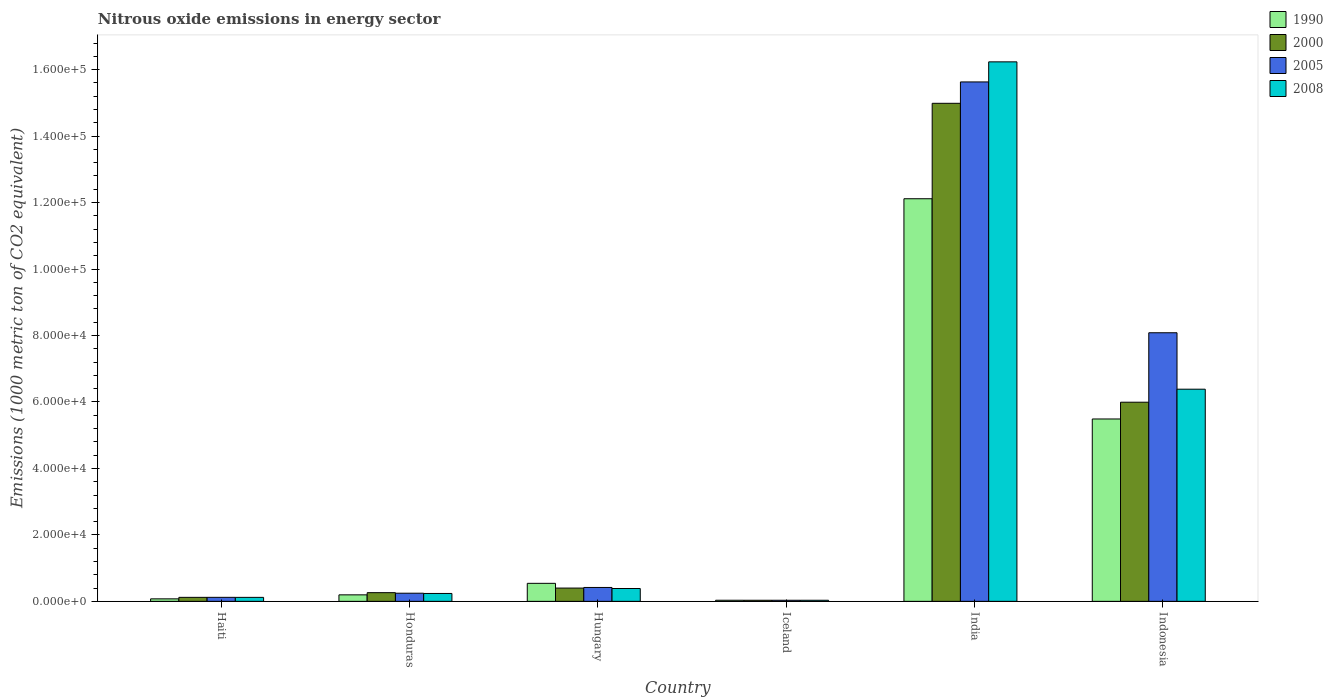How many different coloured bars are there?
Keep it short and to the point. 4. How many groups of bars are there?
Make the answer very short. 6. How many bars are there on the 6th tick from the left?
Provide a short and direct response. 4. What is the amount of nitrous oxide emitted in 2005 in Hungary?
Your answer should be compact. 4181.2. Across all countries, what is the maximum amount of nitrous oxide emitted in 2008?
Provide a short and direct response. 1.62e+05. Across all countries, what is the minimum amount of nitrous oxide emitted in 2000?
Ensure brevity in your answer.  331.8. In which country was the amount of nitrous oxide emitted in 2008 maximum?
Give a very brief answer. India. In which country was the amount of nitrous oxide emitted in 2008 minimum?
Ensure brevity in your answer.  Iceland. What is the total amount of nitrous oxide emitted in 2005 in the graph?
Provide a short and direct response. 2.45e+05. What is the difference between the amount of nitrous oxide emitted in 2008 in Honduras and that in Iceland?
Your answer should be very brief. 2046.1. What is the difference between the amount of nitrous oxide emitted in 2008 in Iceland and the amount of nitrous oxide emitted in 2005 in Indonesia?
Give a very brief answer. -8.05e+04. What is the average amount of nitrous oxide emitted in 2005 per country?
Provide a succinct answer. 4.09e+04. What is the difference between the amount of nitrous oxide emitted of/in 2000 and amount of nitrous oxide emitted of/in 1990 in Iceland?
Provide a succinct answer. -4.5. In how many countries, is the amount of nitrous oxide emitted in 2000 greater than 16000 1000 metric ton?
Provide a succinct answer. 2. What is the ratio of the amount of nitrous oxide emitted in 1990 in Haiti to that in Honduras?
Your response must be concise. 0.39. Is the difference between the amount of nitrous oxide emitted in 2000 in Iceland and India greater than the difference between the amount of nitrous oxide emitted in 1990 in Iceland and India?
Provide a succinct answer. No. What is the difference between the highest and the second highest amount of nitrous oxide emitted in 2008?
Your answer should be compact. 6.00e+04. What is the difference between the highest and the lowest amount of nitrous oxide emitted in 2008?
Offer a very short reply. 1.62e+05. In how many countries, is the amount of nitrous oxide emitted in 2000 greater than the average amount of nitrous oxide emitted in 2000 taken over all countries?
Give a very brief answer. 2. Is the sum of the amount of nitrous oxide emitted in 2008 in Honduras and Iceland greater than the maximum amount of nitrous oxide emitted in 1990 across all countries?
Keep it short and to the point. No. Is it the case that in every country, the sum of the amount of nitrous oxide emitted in 1990 and amount of nitrous oxide emitted in 2008 is greater than the sum of amount of nitrous oxide emitted in 2005 and amount of nitrous oxide emitted in 2000?
Keep it short and to the point. No. What does the 3rd bar from the left in Hungary represents?
Your response must be concise. 2005. Is it the case that in every country, the sum of the amount of nitrous oxide emitted in 2008 and amount of nitrous oxide emitted in 1990 is greater than the amount of nitrous oxide emitted in 2000?
Provide a succinct answer. Yes. How many bars are there?
Give a very brief answer. 24. Are all the bars in the graph horizontal?
Make the answer very short. No. What is the difference between two consecutive major ticks on the Y-axis?
Offer a very short reply. 2.00e+04. Does the graph contain grids?
Make the answer very short. No. Where does the legend appear in the graph?
Provide a short and direct response. Top right. How many legend labels are there?
Make the answer very short. 4. How are the legend labels stacked?
Keep it short and to the point. Vertical. What is the title of the graph?
Give a very brief answer. Nitrous oxide emissions in energy sector. What is the label or title of the X-axis?
Your response must be concise. Country. What is the label or title of the Y-axis?
Your answer should be very brief. Emissions (1000 metric ton of CO2 equivalent). What is the Emissions (1000 metric ton of CO2 equivalent) of 1990 in Haiti?
Make the answer very short. 753.5. What is the Emissions (1000 metric ton of CO2 equivalent) in 2000 in Haiti?
Your answer should be very brief. 1206.3. What is the Emissions (1000 metric ton of CO2 equivalent) of 2005 in Haiti?
Make the answer very short. 1211.1. What is the Emissions (1000 metric ton of CO2 equivalent) in 2008 in Haiti?
Your answer should be compact. 1203.2. What is the Emissions (1000 metric ton of CO2 equivalent) in 1990 in Honduras?
Offer a very short reply. 1956.5. What is the Emissions (1000 metric ton of CO2 equivalent) in 2000 in Honduras?
Your response must be concise. 2615.4. What is the Emissions (1000 metric ton of CO2 equivalent) in 2005 in Honduras?
Provide a short and direct response. 2450.3. What is the Emissions (1000 metric ton of CO2 equivalent) in 2008 in Honduras?
Keep it short and to the point. 2376.9. What is the Emissions (1000 metric ton of CO2 equivalent) in 1990 in Hungary?
Your response must be concise. 5423.5. What is the Emissions (1000 metric ton of CO2 equivalent) of 2000 in Hungary?
Your answer should be very brief. 3996.3. What is the Emissions (1000 metric ton of CO2 equivalent) in 2005 in Hungary?
Ensure brevity in your answer.  4181.2. What is the Emissions (1000 metric ton of CO2 equivalent) in 2008 in Hungary?
Ensure brevity in your answer.  3868. What is the Emissions (1000 metric ton of CO2 equivalent) in 1990 in Iceland?
Your answer should be compact. 336.3. What is the Emissions (1000 metric ton of CO2 equivalent) in 2000 in Iceland?
Your answer should be compact. 331.8. What is the Emissions (1000 metric ton of CO2 equivalent) in 2005 in Iceland?
Provide a short and direct response. 332.8. What is the Emissions (1000 metric ton of CO2 equivalent) in 2008 in Iceland?
Your answer should be compact. 330.8. What is the Emissions (1000 metric ton of CO2 equivalent) of 1990 in India?
Provide a short and direct response. 1.21e+05. What is the Emissions (1000 metric ton of CO2 equivalent) of 2000 in India?
Offer a very short reply. 1.50e+05. What is the Emissions (1000 metric ton of CO2 equivalent) in 2005 in India?
Provide a succinct answer. 1.56e+05. What is the Emissions (1000 metric ton of CO2 equivalent) of 2008 in India?
Your answer should be very brief. 1.62e+05. What is the Emissions (1000 metric ton of CO2 equivalent) of 1990 in Indonesia?
Ensure brevity in your answer.  5.49e+04. What is the Emissions (1000 metric ton of CO2 equivalent) in 2000 in Indonesia?
Your response must be concise. 5.99e+04. What is the Emissions (1000 metric ton of CO2 equivalent) of 2005 in Indonesia?
Keep it short and to the point. 8.08e+04. What is the Emissions (1000 metric ton of CO2 equivalent) of 2008 in Indonesia?
Your answer should be very brief. 6.38e+04. Across all countries, what is the maximum Emissions (1000 metric ton of CO2 equivalent) of 1990?
Keep it short and to the point. 1.21e+05. Across all countries, what is the maximum Emissions (1000 metric ton of CO2 equivalent) of 2000?
Provide a short and direct response. 1.50e+05. Across all countries, what is the maximum Emissions (1000 metric ton of CO2 equivalent) in 2005?
Offer a very short reply. 1.56e+05. Across all countries, what is the maximum Emissions (1000 metric ton of CO2 equivalent) of 2008?
Offer a terse response. 1.62e+05. Across all countries, what is the minimum Emissions (1000 metric ton of CO2 equivalent) in 1990?
Offer a very short reply. 336.3. Across all countries, what is the minimum Emissions (1000 metric ton of CO2 equivalent) in 2000?
Your answer should be very brief. 331.8. Across all countries, what is the minimum Emissions (1000 metric ton of CO2 equivalent) in 2005?
Make the answer very short. 332.8. Across all countries, what is the minimum Emissions (1000 metric ton of CO2 equivalent) in 2008?
Your answer should be compact. 330.8. What is the total Emissions (1000 metric ton of CO2 equivalent) in 1990 in the graph?
Give a very brief answer. 1.85e+05. What is the total Emissions (1000 metric ton of CO2 equivalent) of 2000 in the graph?
Your response must be concise. 2.18e+05. What is the total Emissions (1000 metric ton of CO2 equivalent) of 2005 in the graph?
Your response must be concise. 2.45e+05. What is the total Emissions (1000 metric ton of CO2 equivalent) in 2008 in the graph?
Your answer should be very brief. 2.34e+05. What is the difference between the Emissions (1000 metric ton of CO2 equivalent) in 1990 in Haiti and that in Honduras?
Give a very brief answer. -1203. What is the difference between the Emissions (1000 metric ton of CO2 equivalent) in 2000 in Haiti and that in Honduras?
Keep it short and to the point. -1409.1. What is the difference between the Emissions (1000 metric ton of CO2 equivalent) of 2005 in Haiti and that in Honduras?
Offer a terse response. -1239.2. What is the difference between the Emissions (1000 metric ton of CO2 equivalent) of 2008 in Haiti and that in Honduras?
Your answer should be very brief. -1173.7. What is the difference between the Emissions (1000 metric ton of CO2 equivalent) in 1990 in Haiti and that in Hungary?
Provide a short and direct response. -4670. What is the difference between the Emissions (1000 metric ton of CO2 equivalent) in 2000 in Haiti and that in Hungary?
Offer a very short reply. -2790. What is the difference between the Emissions (1000 metric ton of CO2 equivalent) of 2005 in Haiti and that in Hungary?
Give a very brief answer. -2970.1. What is the difference between the Emissions (1000 metric ton of CO2 equivalent) of 2008 in Haiti and that in Hungary?
Keep it short and to the point. -2664.8. What is the difference between the Emissions (1000 metric ton of CO2 equivalent) in 1990 in Haiti and that in Iceland?
Your answer should be very brief. 417.2. What is the difference between the Emissions (1000 metric ton of CO2 equivalent) in 2000 in Haiti and that in Iceland?
Make the answer very short. 874.5. What is the difference between the Emissions (1000 metric ton of CO2 equivalent) of 2005 in Haiti and that in Iceland?
Keep it short and to the point. 878.3. What is the difference between the Emissions (1000 metric ton of CO2 equivalent) of 2008 in Haiti and that in Iceland?
Keep it short and to the point. 872.4. What is the difference between the Emissions (1000 metric ton of CO2 equivalent) of 1990 in Haiti and that in India?
Offer a terse response. -1.20e+05. What is the difference between the Emissions (1000 metric ton of CO2 equivalent) in 2000 in Haiti and that in India?
Provide a succinct answer. -1.49e+05. What is the difference between the Emissions (1000 metric ton of CO2 equivalent) of 2005 in Haiti and that in India?
Ensure brevity in your answer.  -1.55e+05. What is the difference between the Emissions (1000 metric ton of CO2 equivalent) in 2008 in Haiti and that in India?
Offer a terse response. -1.61e+05. What is the difference between the Emissions (1000 metric ton of CO2 equivalent) of 1990 in Haiti and that in Indonesia?
Offer a terse response. -5.41e+04. What is the difference between the Emissions (1000 metric ton of CO2 equivalent) of 2000 in Haiti and that in Indonesia?
Offer a terse response. -5.87e+04. What is the difference between the Emissions (1000 metric ton of CO2 equivalent) of 2005 in Haiti and that in Indonesia?
Make the answer very short. -7.96e+04. What is the difference between the Emissions (1000 metric ton of CO2 equivalent) of 2008 in Haiti and that in Indonesia?
Offer a very short reply. -6.26e+04. What is the difference between the Emissions (1000 metric ton of CO2 equivalent) in 1990 in Honduras and that in Hungary?
Ensure brevity in your answer.  -3467. What is the difference between the Emissions (1000 metric ton of CO2 equivalent) in 2000 in Honduras and that in Hungary?
Your response must be concise. -1380.9. What is the difference between the Emissions (1000 metric ton of CO2 equivalent) of 2005 in Honduras and that in Hungary?
Provide a short and direct response. -1730.9. What is the difference between the Emissions (1000 metric ton of CO2 equivalent) in 2008 in Honduras and that in Hungary?
Give a very brief answer. -1491.1. What is the difference between the Emissions (1000 metric ton of CO2 equivalent) of 1990 in Honduras and that in Iceland?
Offer a terse response. 1620.2. What is the difference between the Emissions (1000 metric ton of CO2 equivalent) in 2000 in Honduras and that in Iceland?
Your response must be concise. 2283.6. What is the difference between the Emissions (1000 metric ton of CO2 equivalent) of 2005 in Honduras and that in Iceland?
Your answer should be compact. 2117.5. What is the difference between the Emissions (1000 metric ton of CO2 equivalent) in 2008 in Honduras and that in Iceland?
Give a very brief answer. 2046.1. What is the difference between the Emissions (1000 metric ton of CO2 equivalent) of 1990 in Honduras and that in India?
Keep it short and to the point. -1.19e+05. What is the difference between the Emissions (1000 metric ton of CO2 equivalent) in 2000 in Honduras and that in India?
Your answer should be compact. -1.47e+05. What is the difference between the Emissions (1000 metric ton of CO2 equivalent) of 2005 in Honduras and that in India?
Give a very brief answer. -1.54e+05. What is the difference between the Emissions (1000 metric ton of CO2 equivalent) in 2008 in Honduras and that in India?
Offer a very short reply. -1.60e+05. What is the difference between the Emissions (1000 metric ton of CO2 equivalent) of 1990 in Honduras and that in Indonesia?
Offer a terse response. -5.29e+04. What is the difference between the Emissions (1000 metric ton of CO2 equivalent) of 2000 in Honduras and that in Indonesia?
Provide a succinct answer. -5.73e+04. What is the difference between the Emissions (1000 metric ton of CO2 equivalent) in 2005 in Honduras and that in Indonesia?
Your answer should be very brief. -7.84e+04. What is the difference between the Emissions (1000 metric ton of CO2 equivalent) of 2008 in Honduras and that in Indonesia?
Offer a very short reply. -6.15e+04. What is the difference between the Emissions (1000 metric ton of CO2 equivalent) in 1990 in Hungary and that in Iceland?
Offer a very short reply. 5087.2. What is the difference between the Emissions (1000 metric ton of CO2 equivalent) of 2000 in Hungary and that in Iceland?
Your answer should be very brief. 3664.5. What is the difference between the Emissions (1000 metric ton of CO2 equivalent) in 2005 in Hungary and that in Iceland?
Provide a succinct answer. 3848.4. What is the difference between the Emissions (1000 metric ton of CO2 equivalent) in 2008 in Hungary and that in Iceland?
Ensure brevity in your answer.  3537.2. What is the difference between the Emissions (1000 metric ton of CO2 equivalent) of 1990 in Hungary and that in India?
Keep it short and to the point. -1.16e+05. What is the difference between the Emissions (1000 metric ton of CO2 equivalent) in 2000 in Hungary and that in India?
Offer a very short reply. -1.46e+05. What is the difference between the Emissions (1000 metric ton of CO2 equivalent) of 2005 in Hungary and that in India?
Your response must be concise. -1.52e+05. What is the difference between the Emissions (1000 metric ton of CO2 equivalent) of 2008 in Hungary and that in India?
Your answer should be compact. -1.58e+05. What is the difference between the Emissions (1000 metric ton of CO2 equivalent) in 1990 in Hungary and that in Indonesia?
Ensure brevity in your answer.  -4.95e+04. What is the difference between the Emissions (1000 metric ton of CO2 equivalent) of 2000 in Hungary and that in Indonesia?
Your answer should be compact. -5.59e+04. What is the difference between the Emissions (1000 metric ton of CO2 equivalent) in 2005 in Hungary and that in Indonesia?
Your response must be concise. -7.66e+04. What is the difference between the Emissions (1000 metric ton of CO2 equivalent) of 2008 in Hungary and that in Indonesia?
Your answer should be compact. -6.00e+04. What is the difference between the Emissions (1000 metric ton of CO2 equivalent) in 1990 in Iceland and that in India?
Provide a short and direct response. -1.21e+05. What is the difference between the Emissions (1000 metric ton of CO2 equivalent) in 2000 in Iceland and that in India?
Provide a succinct answer. -1.50e+05. What is the difference between the Emissions (1000 metric ton of CO2 equivalent) in 2005 in Iceland and that in India?
Give a very brief answer. -1.56e+05. What is the difference between the Emissions (1000 metric ton of CO2 equivalent) of 2008 in Iceland and that in India?
Your answer should be very brief. -1.62e+05. What is the difference between the Emissions (1000 metric ton of CO2 equivalent) of 1990 in Iceland and that in Indonesia?
Keep it short and to the point. -5.45e+04. What is the difference between the Emissions (1000 metric ton of CO2 equivalent) in 2000 in Iceland and that in Indonesia?
Ensure brevity in your answer.  -5.96e+04. What is the difference between the Emissions (1000 metric ton of CO2 equivalent) of 2005 in Iceland and that in Indonesia?
Keep it short and to the point. -8.05e+04. What is the difference between the Emissions (1000 metric ton of CO2 equivalent) in 2008 in Iceland and that in Indonesia?
Ensure brevity in your answer.  -6.35e+04. What is the difference between the Emissions (1000 metric ton of CO2 equivalent) in 1990 in India and that in Indonesia?
Ensure brevity in your answer.  6.63e+04. What is the difference between the Emissions (1000 metric ton of CO2 equivalent) of 2000 in India and that in Indonesia?
Give a very brief answer. 8.99e+04. What is the difference between the Emissions (1000 metric ton of CO2 equivalent) of 2005 in India and that in Indonesia?
Offer a terse response. 7.55e+04. What is the difference between the Emissions (1000 metric ton of CO2 equivalent) of 2008 in India and that in Indonesia?
Offer a very short reply. 9.85e+04. What is the difference between the Emissions (1000 metric ton of CO2 equivalent) in 1990 in Haiti and the Emissions (1000 metric ton of CO2 equivalent) in 2000 in Honduras?
Keep it short and to the point. -1861.9. What is the difference between the Emissions (1000 metric ton of CO2 equivalent) of 1990 in Haiti and the Emissions (1000 metric ton of CO2 equivalent) of 2005 in Honduras?
Your response must be concise. -1696.8. What is the difference between the Emissions (1000 metric ton of CO2 equivalent) of 1990 in Haiti and the Emissions (1000 metric ton of CO2 equivalent) of 2008 in Honduras?
Ensure brevity in your answer.  -1623.4. What is the difference between the Emissions (1000 metric ton of CO2 equivalent) of 2000 in Haiti and the Emissions (1000 metric ton of CO2 equivalent) of 2005 in Honduras?
Your answer should be compact. -1244. What is the difference between the Emissions (1000 metric ton of CO2 equivalent) in 2000 in Haiti and the Emissions (1000 metric ton of CO2 equivalent) in 2008 in Honduras?
Your answer should be very brief. -1170.6. What is the difference between the Emissions (1000 metric ton of CO2 equivalent) in 2005 in Haiti and the Emissions (1000 metric ton of CO2 equivalent) in 2008 in Honduras?
Provide a short and direct response. -1165.8. What is the difference between the Emissions (1000 metric ton of CO2 equivalent) in 1990 in Haiti and the Emissions (1000 metric ton of CO2 equivalent) in 2000 in Hungary?
Make the answer very short. -3242.8. What is the difference between the Emissions (1000 metric ton of CO2 equivalent) of 1990 in Haiti and the Emissions (1000 metric ton of CO2 equivalent) of 2005 in Hungary?
Offer a very short reply. -3427.7. What is the difference between the Emissions (1000 metric ton of CO2 equivalent) in 1990 in Haiti and the Emissions (1000 metric ton of CO2 equivalent) in 2008 in Hungary?
Provide a short and direct response. -3114.5. What is the difference between the Emissions (1000 metric ton of CO2 equivalent) of 2000 in Haiti and the Emissions (1000 metric ton of CO2 equivalent) of 2005 in Hungary?
Offer a terse response. -2974.9. What is the difference between the Emissions (1000 metric ton of CO2 equivalent) in 2000 in Haiti and the Emissions (1000 metric ton of CO2 equivalent) in 2008 in Hungary?
Provide a short and direct response. -2661.7. What is the difference between the Emissions (1000 metric ton of CO2 equivalent) in 2005 in Haiti and the Emissions (1000 metric ton of CO2 equivalent) in 2008 in Hungary?
Keep it short and to the point. -2656.9. What is the difference between the Emissions (1000 metric ton of CO2 equivalent) of 1990 in Haiti and the Emissions (1000 metric ton of CO2 equivalent) of 2000 in Iceland?
Your answer should be very brief. 421.7. What is the difference between the Emissions (1000 metric ton of CO2 equivalent) of 1990 in Haiti and the Emissions (1000 metric ton of CO2 equivalent) of 2005 in Iceland?
Make the answer very short. 420.7. What is the difference between the Emissions (1000 metric ton of CO2 equivalent) in 1990 in Haiti and the Emissions (1000 metric ton of CO2 equivalent) in 2008 in Iceland?
Give a very brief answer. 422.7. What is the difference between the Emissions (1000 metric ton of CO2 equivalent) in 2000 in Haiti and the Emissions (1000 metric ton of CO2 equivalent) in 2005 in Iceland?
Keep it short and to the point. 873.5. What is the difference between the Emissions (1000 metric ton of CO2 equivalent) of 2000 in Haiti and the Emissions (1000 metric ton of CO2 equivalent) of 2008 in Iceland?
Ensure brevity in your answer.  875.5. What is the difference between the Emissions (1000 metric ton of CO2 equivalent) in 2005 in Haiti and the Emissions (1000 metric ton of CO2 equivalent) in 2008 in Iceland?
Ensure brevity in your answer.  880.3. What is the difference between the Emissions (1000 metric ton of CO2 equivalent) of 1990 in Haiti and the Emissions (1000 metric ton of CO2 equivalent) of 2000 in India?
Keep it short and to the point. -1.49e+05. What is the difference between the Emissions (1000 metric ton of CO2 equivalent) in 1990 in Haiti and the Emissions (1000 metric ton of CO2 equivalent) in 2005 in India?
Provide a succinct answer. -1.56e+05. What is the difference between the Emissions (1000 metric ton of CO2 equivalent) in 1990 in Haiti and the Emissions (1000 metric ton of CO2 equivalent) in 2008 in India?
Offer a terse response. -1.62e+05. What is the difference between the Emissions (1000 metric ton of CO2 equivalent) in 2000 in Haiti and the Emissions (1000 metric ton of CO2 equivalent) in 2005 in India?
Make the answer very short. -1.55e+05. What is the difference between the Emissions (1000 metric ton of CO2 equivalent) in 2000 in Haiti and the Emissions (1000 metric ton of CO2 equivalent) in 2008 in India?
Give a very brief answer. -1.61e+05. What is the difference between the Emissions (1000 metric ton of CO2 equivalent) of 2005 in Haiti and the Emissions (1000 metric ton of CO2 equivalent) of 2008 in India?
Your answer should be very brief. -1.61e+05. What is the difference between the Emissions (1000 metric ton of CO2 equivalent) of 1990 in Haiti and the Emissions (1000 metric ton of CO2 equivalent) of 2000 in Indonesia?
Your response must be concise. -5.92e+04. What is the difference between the Emissions (1000 metric ton of CO2 equivalent) in 1990 in Haiti and the Emissions (1000 metric ton of CO2 equivalent) in 2005 in Indonesia?
Offer a very short reply. -8.01e+04. What is the difference between the Emissions (1000 metric ton of CO2 equivalent) of 1990 in Haiti and the Emissions (1000 metric ton of CO2 equivalent) of 2008 in Indonesia?
Provide a succinct answer. -6.31e+04. What is the difference between the Emissions (1000 metric ton of CO2 equivalent) of 2000 in Haiti and the Emissions (1000 metric ton of CO2 equivalent) of 2005 in Indonesia?
Your answer should be very brief. -7.96e+04. What is the difference between the Emissions (1000 metric ton of CO2 equivalent) in 2000 in Haiti and the Emissions (1000 metric ton of CO2 equivalent) in 2008 in Indonesia?
Offer a terse response. -6.26e+04. What is the difference between the Emissions (1000 metric ton of CO2 equivalent) of 2005 in Haiti and the Emissions (1000 metric ton of CO2 equivalent) of 2008 in Indonesia?
Make the answer very short. -6.26e+04. What is the difference between the Emissions (1000 metric ton of CO2 equivalent) of 1990 in Honduras and the Emissions (1000 metric ton of CO2 equivalent) of 2000 in Hungary?
Make the answer very short. -2039.8. What is the difference between the Emissions (1000 metric ton of CO2 equivalent) in 1990 in Honduras and the Emissions (1000 metric ton of CO2 equivalent) in 2005 in Hungary?
Your answer should be very brief. -2224.7. What is the difference between the Emissions (1000 metric ton of CO2 equivalent) in 1990 in Honduras and the Emissions (1000 metric ton of CO2 equivalent) in 2008 in Hungary?
Make the answer very short. -1911.5. What is the difference between the Emissions (1000 metric ton of CO2 equivalent) of 2000 in Honduras and the Emissions (1000 metric ton of CO2 equivalent) of 2005 in Hungary?
Keep it short and to the point. -1565.8. What is the difference between the Emissions (1000 metric ton of CO2 equivalent) of 2000 in Honduras and the Emissions (1000 metric ton of CO2 equivalent) of 2008 in Hungary?
Provide a short and direct response. -1252.6. What is the difference between the Emissions (1000 metric ton of CO2 equivalent) in 2005 in Honduras and the Emissions (1000 metric ton of CO2 equivalent) in 2008 in Hungary?
Your answer should be compact. -1417.7. What is the difference between the Emissions (1000 metric ton of CO2 equivalent) in 1990 in Honduras and the Emissions (1000 metric ton of CO2 equivalent) in 2000 in Iceland?
Your answer should be compact. 1624.7. What is the difference between the Emissions (1000 metric ton of CO2 equivalent) of 1990 in Honduras and the Emissions (1000 metric ton of CO2 equivalent) of 2005 in Iceland?
Offer a terse response. 1623.7. What is the difference between the Emissions (1000 metric ton of CO2 equivalent) in 1990 in Honduras and the Emissions (1000 metric ton of CO2 equivalent) in 2008 in Iceland?
Give a very brief answer. 1625.7. What is the difference between the Emissions (1000 metric ton of CO2 equivalent) of 2000 in Honduras and the Emissions (1000 metric ton of CO2 equivalent) of 2005 in Iceland?
Offer a terse response. 2282.6. What is the difference between the Emissions (1000 metric ton of CO2 equivalent) in 2000 in Honduras and the Emissions (1000 metric ton of CO2 equivalent) in 2008 in Iceland?
Ensure brevity in your answer.  2284.6. What is the difference between the Emissions (1000 metric ton of CO2 equivalent) of 2005 in Honduras and the Emissions (1000 metric ton of CO2 equivalent) of 2008 in Iceland?
Ensure brevity in your answer.  2119.5. What is the difference between the Emissions (1000 metric ton of CO2 equivalent) in 1990 in Honduras and the Emissions (1000 metric ton of CO2 equivalent) in 2000 in India?
Ensure brevity in your answer.  -1.48e+05. What is the difference between the Emissions (1000 metric ton of CO2 equivalent) of 1990 in Honduras and the Emissions (1000 metric ton of CO2 equivalent) of 2005 in India?
Your response must be concise. -1.54e+05. What is the difference between the Emissions (1000 metric ton of CO2 equivalent) in 1990 in Honduras and the Emissions (1000 metric ton of CO2 equivalent) in 2008 in India?
Ensure brevity in your answer.  -1.60e+05. What is the difference between the Emissions (1000 metric ton of CO2 equivalent) in 2000 in Honduras and the Emissions (1000 metric ton of CO2 equivalent) in 2005 in India?
Ensure brevity in your answer.  -1.54e+05. What is the difference between the Emissions (1000 metric ton of CO2 equivalent) of 2000 in Honduras and the Emissions (1000 metric ton of CO2 equivalent) of 2008 in India?
Your response must be concise. -1.60e+05. What is the difference between the Emissions (1000 metric ton of CO2 equivalent) of 2005 in Honduras and the Emissions (1000 metric ton of CO2 equivalent) of 2008 in India?
Your answer should be compact. -1.60e+05. What is the difference between the Emissions (1000 metric ton of CO2 equivalent) of 1990 in Honduras and the Emissions (1000 metric ton of CO2 equivalent) of 2000 in Indonesia?
Your response must be concise. -5.80e+04. What is the difference between the Emissions (1000 metric ton of CO2 equivalent) of 1990 in Honduras and the Emissions (1000 metric ton of CO2 equivalent) of 2005 in Indonesia?
Your response must be concise. -7.89e+04. What is the difference between the Emissions (1000 metric ton of CO2 equivalent) in 1990 in Honduras and the Emissions (1000 metric ton of CO2 equivalent) in 2008 in Indonesia?
Your response must be concise. -6.19e+04. What is the difference between the Emissions (1000 metric ton of CO2 equivalent) in 2000 in Honduras and the Emissions (1000 metric ton of CO2 equivalent) in 2005 in Indonesia?
Ensure brevity in your answer.  -7.82e+04. What is the difference between the Emissions (1000 metric ton of CO2 equivalent) in 2000 in Honduras and the Emissions (1000 metric ton of CO2 equivalent) in 2008 in Indonesia?
Keep it short and to the point. -6.12e+04. What is the difference between the Emissions (1000 metric ton of CO2 equivalent) of 2005 in Honduras and the Emissions (1000 metric ton of CO2 equivalent) of 2008 in Indonesia?
Offer a very short reply. -6.14e+04. What is the difference between the Emissions (1000 metric ton of CO2 equivalent) of 1990 in Hungary and the Emissions (1000 metric ton of CO2 equivalent) of 2000 in Iceland?
Keep it short and to the point. 5091.7. What is the difference between the Emissions (1000 metric ton of CO2 equivalent) in 1990 in Hungary and the Emissions (1000 metric ton of CO2 equivalent) in 2005 in Iceland?
Keep it short and to the point. 5090.7. What is the difference between the Emissions (1000 metric ton of CO2 equivalent) of 1990 in Hungary and the Emissions (1000 metric ton of CO2 equivalent) of 2008 in Iceland?
Provide a succinct answer. 5092.7. What is the difference between the Emissions (1000 metric ton of CO2 equivalent) in 2000 in Hungary and the Emissions (1000 metric ton of CO2 equivalent) in 2005 in Iceland?
Your answer should be compact. 3663.5. What is the difference between the Emissions (1000 metric ton of CO2 equivalent) in 2000 in Hungary and the Emissions (1000 metric ton of CO2 equivalent) in 2008 in Iceland?
Provide a short and direct response. 3665.5. What is the difference between the Emissions (1000 metric ton of CO2 equivalent) in 2005 in Hungary and the Emissions (1000 metric ton of CO2 equivalent) in 2008 in Iceland?
Make the answer very short. 3850.4. What is the difference between the Emissions (1000 metric ton of CO2 equivalent) of 1990 in Hungary and the Emissions (1000 metric ton of CO2 equivalent) of 2000 in India?
Offer a terse response. -1.44e+05. What is the difference between the Emissions (1000 metric ton of CO2 equivalent) in 1990 in Hungary and the Emissions (1000 metric ton of CO2 equivalent) in 2005 in India?
Your answer should be compact. -1.51e+05. What is the difference between the Emissions (1000 metric ton of CO2 equivalent) of 1990 in Hungary and the Emissions (1000 metric ton of CO2 equivalent) of 2008 in India?
Provide a short and direct response. -1.57e+05. What is the difference between the Emissions (1000 metric ton of CO2 equivalent) in 2000 in Hungary and the Emissions (1000 metric ton of CO2 equivalent) in 2005 in India?
Offer a terse response. -1.52e+05. What is the difference between the Emissions (1000 metric ton of CO2 equivalent) of 2000 in Hungary and the Emissions (1000 metric ton of CO2 equivalent) of 2008 in India?
Your response must be concise. -1.58e+05. What is the difference between the Emissions (1000 metric ton of CO2 equivalent) in 2005 in Hungary and the Emissions (1000 metric ton of CO2 equivalent) in 2008 in India?
Your answer should be compact. -1.58e+05. What is the difference between the Emissions (1000 metric ton of CO2 equivalent) in 1990 in Hungary and the Emissions (1000 metric ton of CO2 equivalent) in 2000 in Indonesia?
Give a very brief answer. -5.45e+04. What is the difference between the Emissions (1000 metric ton of CO2 equivalent) of 1990 in Hungary and the Emissions (1000 metric ton of CO2 equivalent) of 2005 in Indonesia?
Keep it short and to the point. -7.54e+04. What is the difference between the Emissions (1000 metric ton of CO2 equivalent) in 1990 in Hungary and the Emissions (1000 metric ton of CO2 equivalent) in 2008 in Indonesia?
Keep it short and to the point. -5.84e+04. What is the difference between the Emissions (1000 metric ton of CO2 equivalent) in 2000 in Hungary and the Emissions (1000 metric ton of CO2 equivalent) in 2005 in Indonesia?
Your answer should be very brief. -7.68e+04. What is the difference between the Emissions (1000 metric ton of CO2 equivalent) of 2000 in Hungary and the Emissions (1000 metric ton of CO2 equivalent) of 2008 in Indonesia?
Make the answer very short. -5.98e+04. What is the difference between the Emissions (1000 metric ton of CO2 equivalent) of 2005 in Hungary and the Emissions (1000 metric ton of CO2 equivalent) of 2008 in Indonesia?
Offer a terse response. -5.97e+04. What is the difference between the Emissions (1000 metric ton of CO2 equivalent) in 1990 in Iceland and the Emissions (1000 metric ton of CO2 equivalent) in 2000 in India?
Offer a very short reply. -1.50e+05. What is the difference between the Emissions (1000 metric ton of CO2 equivalent) in 1990 in Iceland and the Emissions (1000 metric ton of CO2 equivalent) in 2005 in India?
Provide a short and direct response. -1.56e+05. What is the difference between the Emissions (1000 metric ton of CO2 equivalent) of 1990 in Iceland and the Emissions (1000 metric ton of CO2 equivalent) of 2008 in India?
Ensure brevity in your answer.  -1.62e+05. What is the difference between the Emissions (1000 metric ton of CO2 equivalent) of 2000 in Iceland and the Emissions (1000 metric ton of CO2 equivalent) of 2005 in India?
Provide a succinct answer. -1.56e+05. What is the difference between the Emissions (1000 metric ton of CO2 equivalent) of 2000 in Iceland and the Emissions (1000 metric ton of CO2 equivalent) of 2008 in India?
Your answer should be very brief. -1.62e+05. What is the difference between the Emissions (1000 metric ton of CO2 equivalent) of 2005 in Iceland and the Emissions (1000 metric ton of CO2 equivalent) of 2008 in India?
Provide a succinct answer. -1.62e+05. What is the difference between the Emissions (1000 metric ton of CO2 equivalent) of 1990 in Iceland and the Emissions (1000 metric ton of CO2 equivalent) of 2000 in Indonesia?
Offer a very short reply. -5.96e+04. What is the difference between the Emissions (1000 metric ton of CO2 equivalent) in 1990 in Iceland and the Emissions (1000 metric ton of CO2 equivalent) in 2005 in Indonesia?
Give a very brief answer. -8.05e+04. What is the difference between the Emissions (1000 metric ton of CO2 equivalent) in 1990 in Iceland and the Emissions (1000 metric ton of CO2 equivalent) in 2008 in Indonesia?
Provide a succinct answer. -6.35e+04. What is the difference between the Emissions (1000 metric ton of CO2 equivalent) of 2000 in Iceland and the Emissions (1000 metric ton of CO2 equivalent) of 2005 in Indonesia?
Keep it short and to the point. -8.05e+04. What is the difference between the Emissions (1000 metric ton of CO2 equivalent) in 2000 in Iceland and the Emissions (1000 metric ton of CO2 equivalent) in 2008 in Indonesia?
Provide a succinct answer. -6.35e+04. What is the difference between the Emissions (1000 metric ton of CO2 equivalent) in 2005 in Iceland and the Emissions (1000 metric ton of CO2 equivalent) in 2008 in Indonesia?
Your answer should be compact. -6.35e+04. What is the difference between the Emissions (1000 metric ton of CO2 equivalent) in 1990 in India and the Emissions (1000 metric ton of CO2 equivalent) in 2000 in Indonesia?
Your response must be concise. 6.12e+04. What is the difference between the Emissions (1000 metric ton of CO2 equivalent) in 1990 in India and the Emissions (1000 metric ton of CO2 equivalent) in 2005 in Indonesia?
Keep it short and to the point. 4.03e+04. What is the difference between the Emissions (1000 metric ton of CO2 equivalent) in 1990 in India and the Emissions (1000 metric ton of CO2 equivalent) in 2008 in Indonesia?
Provide a succinct answer. 5.73e+04. What is the difference between the Emissions (1000 metric ton of CO2 equivalent) in 2000 in India and the Emissions (1000 metric ton of CO2 equivalent) in 2005 in Indonesia?
Offer a terse response. 6.90e+04. What is the difference between the Emissions (1000 metric ton of CO2 equivalent) in 2000 in India and the Emissions (1000 metric ton of CO2 equivalent) in 2008 in Indonesia?
Offer a very short reply. 8.60e+04. What is the difference between the Emissions (1000 metric ton of CO2 equivalent) in 2005 in India and the Emissions (1000 metric ton of CO2 equivalent) in 2008 in Indonesia?
Your response must be concise. 9.25e+04. What is the average Emissions (1000 metric ton of CO2 equivalent) in 1990 per country?
Your response must be concise. 3.08e+04. What is the average Emissions (1000 metric ton of CO2 equivalent) in 2000 per country?
Your answer should be compact. 3.63e+04. What is the average Emissions (1000 metric ton of CO2 equivalent) in 2005 per country?
Keep it short and to the point. 4.09e+04. What is the average Emissions (1000 metric ton of CO2 equivalent) in 2008 per country?
Your response must be concise. 3.90e+04. What is the difference between the Emissions (1000 metric ton of CO2 equivalent) in 1990 and Emissions (1000 metric ton of CO2 equivalent) in 2000 in Haiti?
Give a very brief answer. -452.8. What is the difference between the Emissions (1000 metric ton of CO2 equivalent) of 1990 and Emissions (1000 metric ton of CO2 equivalent) of 2005 in Haiti?
Keep it short and to the point. -457.6. What is the difference between the Emissions (1000 metric ton of CO2 equivalent) of 1990 and Emissions (1000 metric ton of CO2 equivalent) of 2008 in Haiti?
Give a very brief answer. -449.7. What is the difference between the Emissions (1000 metric ton of CO2 equivalent) in 2000 and Emissions (1000 metric ton of CO2 equivalent) in 2008 in Haiti?
Your answer should be very brief. 3.1. What is the difference between the Emissions (1000 metric ton of CO2 equivalent) of 1990 and Emissions (1000 metric ton of CO2 equivalent) of 2000 in Honduras?
Offer a very short reply. -658.9. What is the difference between the Emissions (1000 metric ton of CO2 equivalent) of 1990 and Emissions (1000 metric ton of CO2 equivalent) of 2005 in Honduras?
Ensure brevity in your answer.  -493.8. What is the difference between the Emissions (1000 metric ton of CO2 equivalent) in 1990 and Emissions (1000 metric ton of CO2 equivalent) in 2008 in Honduras?
Provide a short and direct response. -420.4. What is the difference between the Emissions (1000 metric ton of CO2 equivalent) in 2000 and Emissions (1000 metric ton of CO2 equivalent) in 2005 in Honduras?
Ensure brevity in your answer.  165.1. What is the difference between the Emissions (1000 metric ton of CO2 equivalent) in 2000 and Emissions (1000 metric ton of CO2 equivalent) in 2008 in Honduras?
Offer a terse response. 238.5. What is the difference between the Emissions (1000 metric ton of CO2 equivalent) of 2005 and Emissions (1000 metric ton of CO2 equivalent) of 2008 in Honduras?
Ensure brevity in your answer.  73.4. What is the difference between the Emissions (1000 metric ton of CO2 equivalent) of 1990 and Emissions (1000 metric ton of CO2 equivalent) of 2000 in Hungary?
Ensure brevity in your answer.  1427.2. What is the difference between the Emissions (1000 metric ton of CO2 equivalent) in 1990 and Emissions (1000 metric ton of CO2 equivalent) in 2005 in Hungary?
Your response must be concise. 1242.3. What is the difference between the Emissions (1000 metric ton of CO2 equivalent) of 1990 and Emissions (1000 metric ton of CO2 equivalent) of 2008 in Hungary?
Give a very brief answer. 1555.5. What is the difference between the Emissions (1000 metric ton of CO2 equivalent) in 2000 and Emissions (1000 metric ton of CO2 equivalent) in 2005 in Hungary?
Offer a terse response. -184.9. What is the difference between the Emissions (1000 metric ton of CO2 equivalent) of 2000 and Emissions (1000 metric ton of CO2 equivalent) of 2008 in Hungary?
Offer a terse response. 128.3. What is the difference between the Emissions (1000 metric ton of CO2 equivalent) of 2005 and Emissions (1000 metric ton of CO2 equivalent) of 2008 in Hungary?
Provide a succinct answer. 313.2. What is the difference between the Emissions (1000 metric ton of CO2 equivalent) of 1990 and Emissions (1000 metric ton of CO2 equivalent) of 2005 in Iceland?
Your answer should be compact. 3.5. What is the difference between the Emissions (1000 metric ton of CO2 equivalent) in 2000 and Emissions (1000 metric ton of CO2 equivalent) in 2005 in Iceland?
Your answer should be very brief. -1. What is the difference between the Emissions (1000 metric ton of CO2 equivalent) of 2000 and Emissions (1000 metric ton of CO2 equivalent) of 2008 in Iceland?
Give a very brief answer. 1. What is the difference between the Emissions (1000 metric ton of CO2 equivalent) of 2005 and Emissions (1000 metric ton of CO2 equivalent) of 2008 in Iceland?
Keep it short and to the point. 2. What is the difference between the Emissions (1000 metric ton of CO2 equivalent) in 1990 and Emissions (1000 metric ton of CO2 equivalent) in 2000 in India?
Provide a short and direct response. -2.87e+04. What is the difference between the Emissions (1000 metric ton of CO2 equivalent) in 1990 and Emissions (1000 metric ton of CO2 equivalent) in 2005 in India?
Offer a terse response. -3.51e+04. What is the difference between the Emissions (1000 metric ton of CO2 equivalent) of 1990 and Emissions (1000 metric ton of CO2 equivalent) of 2008 in India?
Give a very brief answer. -4.12e+04. What is the difference between the Emissions (1000 metric ton of CO2 equivalent) in 2000 and Emissions (1000 metric ton of CO2 equivalent) in 2005 in India?
Your answer should be very brief. -6428.4. What is the difference between the Emissions (1000 metric ton of CO2 equivalent) of 2000 and Emissions (1000 metric ton of CO2 equivalent) of 2008 in India?
Ensure brevity in your answer.  -1.25e+04. What is the difference between the Emissions (1000 metric ton of CO2 equivalent) in 2005 and Emissions (1000 metric ton of CO2 equivalent) in 2008 in India?
Offer a very short reply. -6044.2. What is the difference between the Emissions (1000 metric ton of CO2 equivalent) in 1990 and Emissions (1000 metric ton of CO2 equivalent) in 2000 in Indonesia?
Provide a short and direct response. -5044.7. What is the difference between the Emissions (1000 metric ton of CO2 equivalent) of 1990 and Emissions (1000 metric ton of CO2 equivalent) of 2005 in Indonesia?
Your answer should be very brief. -2.59e+04. What is the difference between the Emissions (1000 metric ton of CO2 equivalent) of 1990 and Emissions (1000 metric ton of CO2 equivalent) of 2008 in Indonesia?
Your answer should be compact. -8962.8. What is the difference between the Emissions (1000 metric ton of CO2 equivalent) of 2000 and Emissions (1000 metric ton of CO2 equivalent) of 2005 in Indonesia?
Keep it short and to the point. -2.09e+04. What is the difference between the Emissions (1000 metric ton of CO2 equivalent) in 2000 and Emissions (1000 metric ton of CO2 equivalent) in 2008 in Indonesia?
Your answer should be compact. -3918.1. What is the difference between the Emissions (1000 metric ton of CO2 equivalent) in 2005 and Emissions (1000 metric ton of CO2 equivalent) in 2008 in Indonesia?
Ensure brevity in your answer.  1.70e+04. What is the ratio of the Emissions (1000 metric ton of CO2 equivalent) in 1990 in Haiti to that in Honduras?
Provide a short and direct response. 0.39. What is the ratio of the Emissions (1000 metric ton of CO2 equivalent) of 2000 in Haiti to that in Honduras?
Ensure brevity in your answer.  0.46. What is the ratio of the Emissions (1000 metric ton of CO2 equivalent) in 2005 in Haiti to that in Honduras?
Your answer should be compact. 0.49. What is the ratio of the Emissions (1000 metric ton of CO2 equivalent) in 2008 in Haiti to that in Honduras?
Make the answer very short. 0.51. What is the ratio of the Emissions (1000 metric ton of CO2 equivalent) of 1990 in Haiti to that in Hungary?
Your response must be concise. 0.14. What is the ratio of the Emissions (1000 metric ton of CO2 equivalent) in 2000 in Haiti to that in Hungary?
Your response must be concise. 0.3. What is the ratio of the Emissions (1000 metric ton of CO2 equivalent) in 2005 in Haiti to that in Hungary?
Give a very brief answer. 0.29. What is the ratio of the Emissions (1000 metric ton of CO2 equivalent) in 2008 in Haiti to that in Hungary?
Provide a succinct answer. 0.31. What is the ratio of the Emissions (1000 metric ton of CO2 equivalent) of 1990 in Haiti to that in Iceland?
Offer a very short reply. 2.24. What is the ratio of the Emissions (1000 metric ton of CO2 equivalent) of 2000 in Haiti to that in Iceland?
Provide a short and direct response. 3.64. What is the ratio of the Emissions (1000 metric ton of CO2 equivalent) in 2005 in Haiti to that in Iceland?
Offer a very short reply. 3.64. What is the ratio of the Emissions (1000 metric ton of CO2 equivalent) of 2008 in Haiti to that in Iceland?
Your response must be concise. 3.64. What is the ratio of the Emissions (1000 metric ton of CO2 equivalent) of 1990 in Haiti to that in India?
Make the answer very short. 0.01. What is the ratio of the Emissions (1000 metric ton of CO2 equivalent) of 2000 in Haiti to that in India?
Offer a terse response. 0.01. What is the ratio of the Emissions (1000 metric ton of CO2 equivalent) in 2005 in Haiti to that in India?
Provide a short and direct response. 0.01. What is the ratio of the Emissions (1000 metric ton of CO2 equivalent) of 2008 in Haiti to that in India?
Ensure brevity in your answer.  0.01. What is the ratio of the Emissions (1000 metric ton of CO2 equivalent) of 1990 in Haiti to that in Indonesia?
Provide a short and direct response. 0.01. What is the ratio of the Emissions (1000 metric ton of CO2 equivalent) of 2000 in Haiti to that in Indonesia?
Your response must be concise. 0.02. What is the ratio of the Emissions (1000 metric ton of CO2 equivalent) in 2005 in Haiti to that in Indonesia?
Offer a very short reply. 0.01. What is the ratio of the Emissions (1000 metric ton of CO2 equivalent) of 2008 in Haiti to that in Indonesia?
Give a very brief answer. 0.02. What is the ratio of the Emissions (1000 metric ton of CO2 equivalent) of 1990 in Honduras to that in Hungary?
Offer a terse response. 0.36. What is the ratio of the Emissions (1000 metric ton of CO2 equivalent) in 2000 in Honduras to that in Hungary?
Provide a short and direct response. 0.65. What is the ratio of the Emissions (1000 metric ton of CO2 equivalent) in 2005 in Honduras to that in Hungary?
Keep it short and to the point. 0.59. What is the ratio of the Emissions (1000 metric ton of CO2 equivalent) in 2008 in Honduras to that in Hungary?
Provide a short and direct response. 0.61. What is the ratio of the Emissions (1000 metric ton of CO2 equivalent) of 1990 in Honduras to that in Iceland?
Your answer should be very brief. 5.82. What is the ratio of the Emissions (1000 metric ton of CO2 equivalent) in 2000 in Honduras to that in Iceland?
Give a very brief answer. 7.88. What is the ratio of the Emissions (1000 metric ton of CO2 equivalent) of 2005 in Honduras to that in Iceland?
Keep it short and to the point. 7.36. What is the ratio of the Emissions (1000 metric ton of CO2 equivalent) in 2008 in Honduras to that in Iceland?
Your answer should be compact. 7.19. What is the ratio of the Emissions (1000 metric ton of CO2 equivalent) of 1990 in Honduras to that in India?
Your response must be concise. 0.02. What is the ratio of the Emissions (1000 metric ton of CO2 equivalent) in 2000 in Honduras to that in India?
Give a very brief answer. 0.02. What is the ratio of the Emissions (1000 metric ton of CO2 equivalent) of 2005 in Honduras to that in India?
Give a very brief answer. 0.02. What is the ratio of the Emissions (1000 metric ton of CO2 equivalent) of 2008 in Honduras to that in India?
Offer a terse response. 0.01. What is the ratio of the Emissions (1000 metric ton of CO2 equivalent) in 1990 in Honduras to that in Indonesia?
Ensure brevity in your answer.  0.04. What is the ratio of the Emissions (1000 metric ton of CO2 equivalent) in 2000 in Honduras to that in Indonesia?
Provide a succinct answer. 0.04. What is the ratio of the Emissions (1000 metric ton of CO2 equivalent) of 2005 in Honduras to that in Indonesia?
Ensure brevity in your answer.  0.03. What is the ratio of the Emissions (1000 metric ton of CO2 equivalent) of 2008 in Honduras to that in Indonesia?
Your answer should be very brief. 0.04. What is the ratio of the Emissions (1000 metric ton of CO2 equivalent) in 1990 in Hungary to that in Iceland?
Your answer should be very brief. 16.13. What is the ratio of the Emissions (1000 metric ton of CO2 equivalent) of 2000 in Hungary to that in Iceland?
Make the answer very short. 12.04. What is the ratio of the Emissions (1000 metric ton of CO2 equivalent) in 2005 in Hungary to that in Iceland?
Provide a short and direct response. 12.56. What is the ratio of the Emissions (1000 metric ton of CO2 equivalent) in 2008 in Hungary to that in Iceland?
Make the answer very short. 11.69. What is the ratio of the Emissions (1000 metric ton of CO2 equivalent) in 1990 in Hungary to that in India?
Provide a succinct answer. 0.04. What is the ratio of the Emissions (1000 metric ton of CO2 equivalent) of 2000 in Hungary to that in India?
Make the answer very short. 0.03. What is the ratio of the Emissions (1000 metric ton of CO2 equivalent) of 2005 in Hungary to that in India?
Your answer should be compact. 0.03. What is the ratio of the Emissions (1000 metric ton of CO2 equivalent) of 2008 in Hungary to that in India?
Provide a succinct answer. 0.02. What is the ratio of the Emissions (1000 metric ton of CO2 equivalent) in 1990 in Hungary to that in Indonesia?
Offer a terse response. 0.1. What is the ratio of the Emissions (1000 metric ton of CO2 equivalent) of 2000 in Hungary to that in Indonesia?
Give a very brief answer. 0.07. What is the ratio of the Emissions (1000 metric ton of CO2 equivalent) of 2005 in Hungary to that in Indonesia?
Keep it short and to the point. 0.05. What is the ratio of the Emissions (1000 metric ton of CO2 equivalent) in 2008 in Hungary to that in Indonesia?
Provide a succinct answer. 0.06. What is the ratio of the Emissions (1000 metric ton of CO2 equivalent) in 1990 in Iceland to that in India?
Provide a short and direct response. 0. What is the ratio of the Emissions (1000 metric ton of CO2 equivalent) of 2000 in Iceland to that in India?
Ensure brevity in your answer.  0. What is the ratio of the Emissions (1000 metric ton of CO2 equivalent) in 2005 in Iceland to that in India?
Make the answer very short. 0. What is the ratio of the Emissions (1000 metric ton of CO2 equivalent) of 2008 in Iceland to that in India?
Offer a terse response. 0. What is the ratio of the Emissions (1000 metric ton of CO2 equivalent) of 1990 in Iceland to that in Indonesia?
Offer a very short reply. 0.01. What is the ratio of the Emissions (1000 metric ton of CO2 equivalent) of 2000 in Iceland to that in Indonesia?
Your answer should be compact. 0.01. What is the ratio of the Emissions (1000 metric ton of CO2 equivalent) of 2005 in Iceland to that in Indonesia?
Give a very brief answer. 0. What is the ratio of the Emissions (1000 metric ton of CO2 equivalent) of 2008 in Iceland to that in Indonesia?
Keep it short and to the point. 0.01. What is the ratio of the Emissions (1000 metric ton of CO2 equivalent) of 1990 in India to that in Indonesia?
Offer a terse response. 2.21. What is the ratio of the Emissions (1000 metric ton of CO2 equivalent) of 2000 in India to that in Indonesia?
Your answer should be compact. 2.5. What is the ratio of the Emissions (1000 metric ton of CO2 equivalent) in 2005 in India to that in Indonesia?
Your answer should be very brief. 1.93. What is the ratio of the Emissions (1000 metric ton of CO2 equivalent) in 2008 in India to that in Indonesia?
Provide a short and direct response. 2.54. What is the difference between the highest and the second highest Emissions (1000 metric ton of CO2 equivalent) in 1990?
Your response must be concise. 6.63e+04. What is the difference between the highest and the second highest Emissions (1000 metric ton of CO2 equivalent) of 2000?
Your answer should be compact. 8.99e+04. What is the difference between the highest and the second highest Emissions (1000 metric ton of CO2 equivalent) of 2005?
Provide a short and direct response. 7.55e+04. What is the difference between the highest and the second highest Emissions (1000 metric ton of CO2 equivalent) in 2008?
Ensure brevity in your answer.  9.85e+04. What is the difference between the highest and the lowest Emissions (1000 metric ton of CO2 equivalent) in 1990?
Your response must be concise. 1.21e+05. What is the difference between the highest and the lowest Emissions (1000 metric ton of CO2 equivalent) in 2000?
Your answer should be compact. 1.50e+05. What is the difference between the highest and the lowest Emissions (1000 metric ton of CO2 equivalent) in 2005?
Your answer should be compact. 1.56e+05. What is the difference between the highest and the lowest Emissions (1000 metric ton of CO2 equivalent) of 2008?
Your response must be concise. 1.62e+05. 